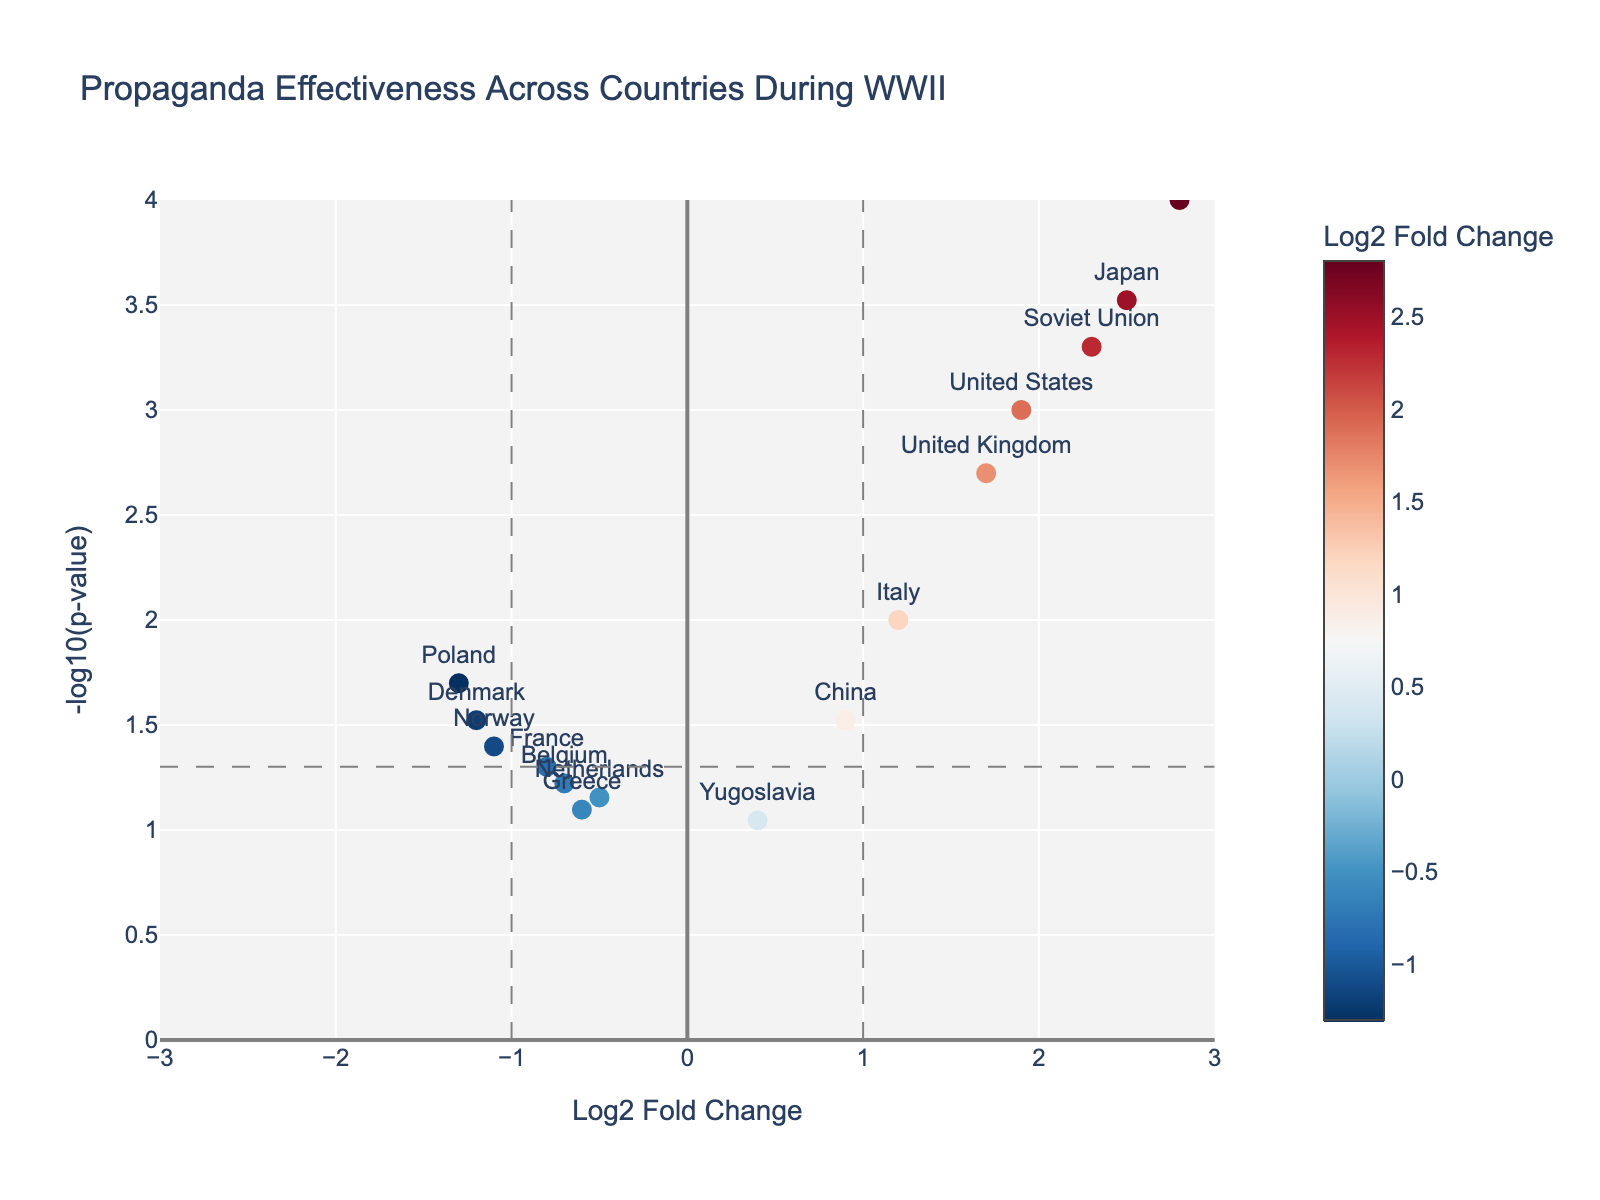How many countries are analyzed in this plot? There are 15 data points, each representing a country. Count the number of different countries labeled on the plot.
Answer: 15 Which country has the highest log2 fold change? Look at the x-axis (Log2 Fold Change). Identify the point with the highest value on this axis.
Answer: Germany Which country has the lowest -log10(p-value)? Look at the y-axis (-log10(p-value)). Identify the point with the lowest value on this axis, meaning the highest p-value.
Answer: Yugoslavia Is the propaganda effectiveness of Germany more significant than that of the United Kingdom? Compare the positions of Germany and the United Kingdom on both the y-axis (-log10(p-value)) and the x-axis (Log2 Fold Change). Germany has higher values on both axes, indicating more significant and effective propaganda.
Answer: Yes What is the log2 fold change for the Soviet Union, and how does it compare to that of the United States? Check the data points for the Soviet Union and the United States on the x-axis (Log2 Fold Change). The log2 fold change for the Soviet Union is 2.3, while for the United States, it is 1.9.
Answer: Soviet Union: 2.3, higher than United States: 1.9 What is the significance threshold line for p-value = 0.05 on the plot? The significance threshold is represented by a horizontal line at -log10(0.05). Calculate -log10(0.05), which equals 1.3, and this line can be visualized on the y-axis at this value.
Answer: -log10(p-value) of 1.3 How many countries have a log2 fold change less than 0? Look at the points to the left of the y-axis (Log2 Fold Change < 0). Count these points.
Answer: 8 Which countries have log2 fold changes between -1 and 1? Look for points within x-values -1 and 1. The countries within this range are France, China, Netherlands, Belgium, Greece, and Yugoslavia.
Answer: 6 countries Compare the effectiveness of propaganda between Japan and Italy. Identify the positions of Japan and Italy on both axes. Japan has a log2 fold change of 2.5 and a -log10(p-value) around 3.52, while Italy has a log2 fold change of 1.2 and a -log10(p-value) around 2. The values indicate Japan's propaganda was more effective.
Answer: Japan's propaganda is more effective Which country shows substantial propaganda effectiveness but has a relatively mediocre p-value compared to others? Look for a country with a high log2 fold change but a lower -log10(p-value). China, with a log2 fold change of 0.9 and a -log10(p-value) of approximately 1.52, fits this description.
Answer: China 